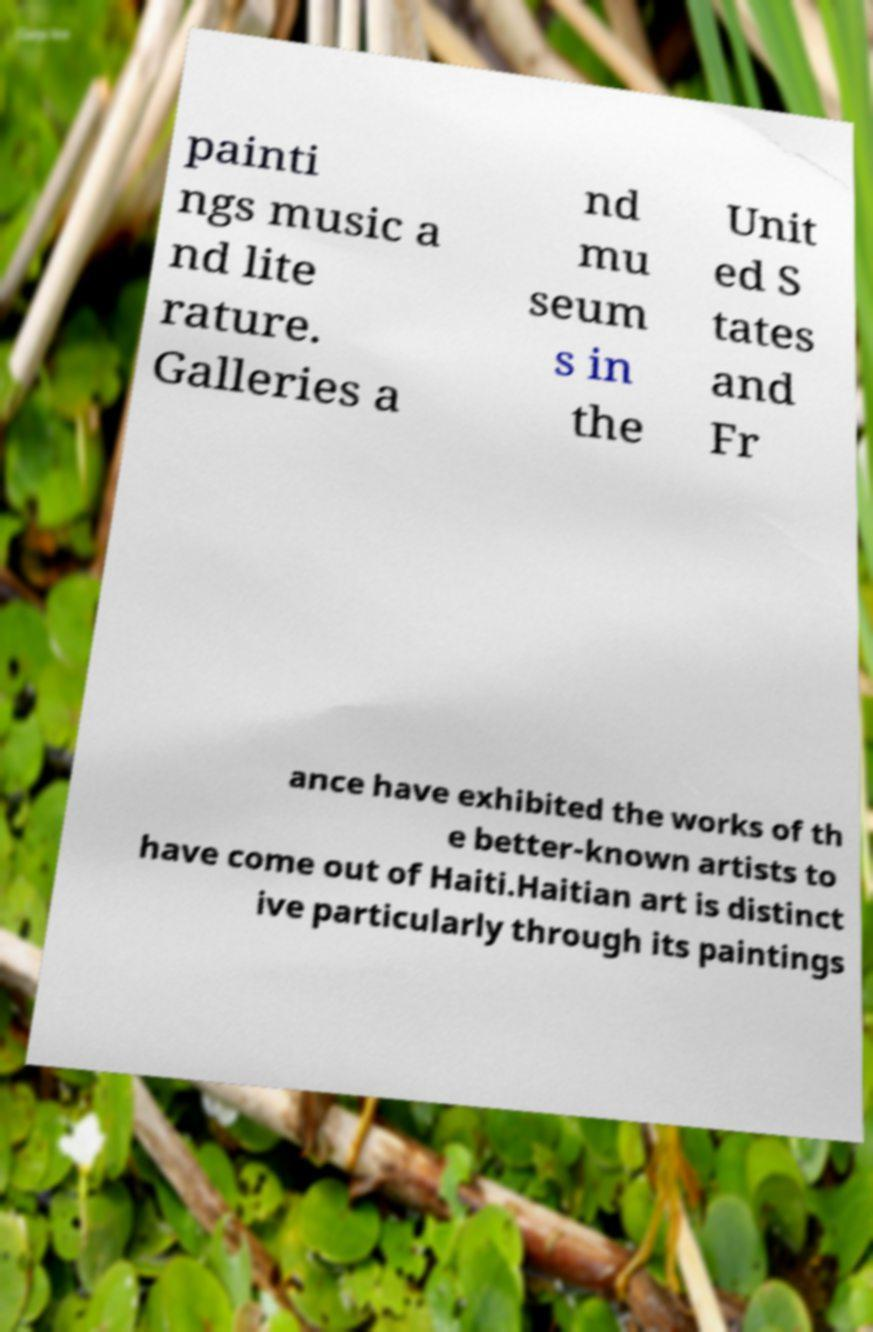Could you assist in decoding the text presented in this image and type it out clearly? painti ngs music a nd lite rature. Galleries a nd mu seum s in the Unit ed S tates and Fr ance have exhibited the works of th e better-known artists to have come out of Haiti.Haitian art is distinct ive particularly through its paintings 